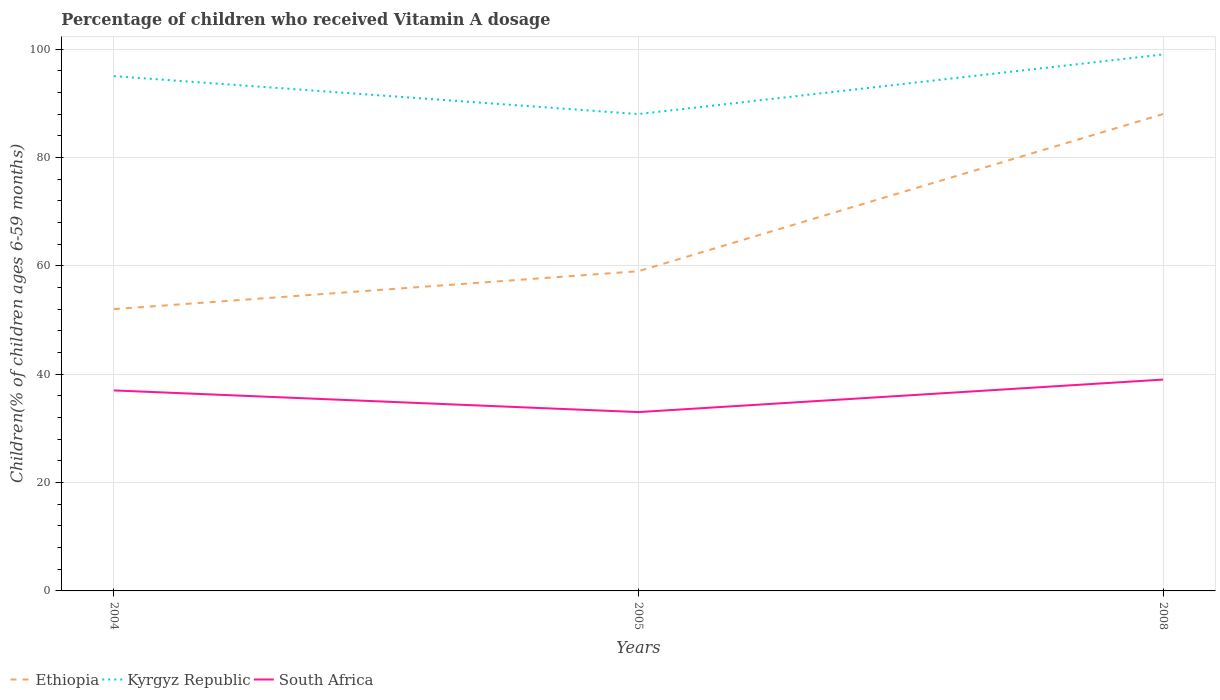Is the number of lines equal to the number of legend labels?
Offer a terse response. Yes. Across all years, what is the maximum percentage of children who received Vitamin A dosage in South Africa?
Offer a terse response. 33. In which year was the percentage of children who received Vitamin A dosage in Ethiopia maximum?
Your answer should be very brief. 2004. What is the total percentage of children who received Vitamin A dosage in Ethiopia in the graph?
Keep it short and to the point. -36. How many lines are there?
Keep it short and to the point. 3. Are the values on the major ticks of Y-axis written in scientific E-notation?
Give a very brief answer. No. Does the graph contain grids?
Give a very brief answer. Yes. Where does the legend appear in the graph?
Offer a terse response. Bottom left. What is the title of the graph?
Keep it short and to the point. Percentage of children who received Vitamin A dosage. What is the label or title of the X-axis?
Make the answer very short. Years. What is the label or title of the Y-axis?
Give a very brief answer. Children(% of children ages 6-59 months). What is the Children(% of children ages 6-59 months) of Ethiopia in 2004?
Provide a succinct answer. 52. What is the Children(% of children ages 6-59 months) of South Africa in 2004?
Your answer should be compact. 37. What is the Children(% of children ages 6-59 months) in Ethiopia in 2005?
Ensure brevity in your answer.  59. What is the Children(% of children ages 6-59 months) in Kyrgyz Republic in 2005?
Offer a very short reply. 88. What is the Children(% of children ages 6-59 months) in South Africa in 2008?
Ensure brevity in your answer.  39. Across all years, what is the maximum Children(% of children ages 6-59 months) of Ethiopia?
Offer a very short reply. 88. Across all years, what is the maximum Children(% of children ages 6-59 months) in Kyrgyz Republic?
Offer a very short reply. 99. Across all years, what is the maximum Children(% of children ages 6-59 months) in South Africa?
Offer a very short reply. 39. Across all years, what is the minimum Children(% of children ages 6-59 months) of Ethiopia?
Keep it short and to the point. 52. Across all years, what is the minimum Children(% of children ages 6-59 months) of Kyrgyz Republic?
Offer a very short reply. 88. Across all years, what is the minimum Children(% of children ages 6-59 months) of South Africa?
Provide a short and direct response. 33. What is the total Children(% of children ages 6-59 months) of Ethiopia in the graph?
Ensure brevity in your answer.  199. What is the total Children(% of children ages 6-59 months) of Kyrgyz Republic in the graph?
Your answer should be very brief. 282. What is the total Children(% of children ages 6-59 months) of South Africa in the graph?
Provide a succinct answer. 109. What is the difference between the Children(% of children ages 6-59 months) of Ethiopia in 2004 and that in 2005?
Offer a very short reply. -7. What is the difference between the Children(% of children ages 6-59 months) of Kyrgyz Republic in 2004 and that in 2005?
Keep it short and to the point. 7. What is the difference between the Children(% of children ages 6-59 months) of Ethiopia in 2004 and that in 2008?
Your answer should be very brief. -36. What is the difference between the Children(% of children ages 6-59 months) in South Africa in 2004 and that in 2008?
Your answer should be very brief. -2. What is the difference between the Children(% of children ages 6-59 months) of Ethiopia in 2005 and that in 2008?
Keep it short and to the point. -29. What is the difference between the Children(% of children ages 6-59 months) in Kyrgyz Republic in 2005 and that in 2008?
Give a very brief answer. -11. What is the difference between the Children(% of children ages 6-59 months) in Ethiopia in 2004 and the Children(% of children ages 6-59 months) in Kyrgyz Republic in 2005?
Offer a very short reply. -36. What is the difference between the Children(% of children ages 6-59 months) of Kyrgyz Republic in 2004 and the Children(% of children ages 6-59 months) of South Africa in 2005?
Your answer should be compact. 62. What is the difference between the Children(% of children ages 6-59 months) in Ethiopia in 2004 and the Children(% of children ages 6-59 months) in Kyrgyz Republic in 2008?
Offer a terse response. -47. What is the difference between the Children(% of children ages 6-59 months) in Kyrgyz Republic in 2004 and the Children(% of children ages 6-59 months) in South Africa in 2008?
Your answer should be very brief. 56. What is the difference between the Children(% of children ages 6-59 months) in Ethiopia in 2005 and the Children(% of children ages 6-59 months) in Kyrgyz Republic in 2008?
Offer a very short reply. -40. What is the average Children(% of children ages 6-59 months) of Ethiopia per year?
Ensure brevity in your answer.  66.33. What is the average Children(% of children ages 6-59 months) in Kyrgyz Republic per year?
Your answer should be compact. 94. What is the average Children(% of children ages 6-59 months) of South Africa per year?
Your response must be concise. 36.33. In the year 2004, what is the difference between the Children(% of children ages 6-59 months) in Ethiopia and Children(% of children ages 6-59 months) in Kyrgyz Republic?
Give a very brief answer. -43. In the year 2004, what is the difference between the Children(% of children ages 6-59 months) in Ethiopia and Children(% of children ages 6-59 months) in South Africa?
Offer a terse response. 15. In the year 2004, what is the difference between the Children(% of children ages 6-59 months) of Kyrgyz Republic and Children(% of children ages 6-59 months) of South Africa?
Your answer should be compact. 58. In the year 2005, what is the difference between the Children(% of children ages 6-59 months) of Ethiopia and Children(% of children ages 6-59 months) of Kyrgyz Republic?
Your answer should be very brief. -29. In the year 2005, what is the difference between the Children(% of children ages 6-59 months) in Kyrgyz Republic and Children(% of children ages 6-59 months) in South Africa?
Give a very brief answer. 55. What is the ratio of the Children(% of children ages 6-59 months) in Ethiopia in 2004 to that in 2005?
Your answer should be compact. 0.88. What is the ratio of the Children(% of children ages 6-59 months) of Kyrgyz Republic in 2004 to that in 2005?
Ensure brevity in your answer.  1.08. What is the ratio of the Children(% of children ages 6-59 months) in South Africa in 2004 to that in 2005?
Your answer should be very brief. 1.12. What is the ratio of the Children(% of children ages 6-59 months) of Ethiopia in 2004 to that in 2008?
Make the answer very short. 0.59. What is the ratio of the Children(% of children ages 6-59 months) in Kyrgyz Republic in 2004 to that in 2008?
Provide a short and direct response. 0.96. What is the ratio of the Children(% of children ages 6-59 months) of South Africa in 2004 to that in 2008?
Offer a terse response. 0.95. What is the ratio of the Children(% of children ages 6-59 months) in Ethiopia in 2005 to that in 2008?
Ensure brevity in your answer.  0.67. What is the ratio of the Children(% of children ages 6-59 months) of Kyrgyz Republic in 2005 to that in 2008?
Keep it short and to the point. 0.89. What is the ratio of the Children(% of children ages 6-59 months) of South Africa in 2005 to that in 2008?
Make the answer very short. 0.85. What is the difference between the highest and the lowest Children(% of children ages 6-59 months) of South Africa?
Your response must be concise. 6. 